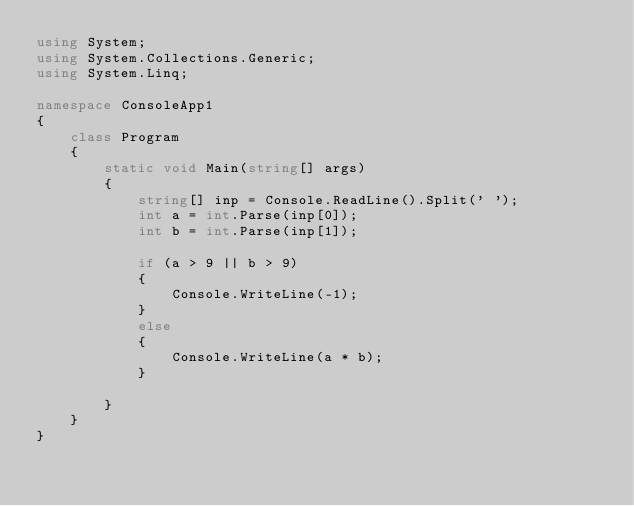Convert code to text. <code><loc_0><loc_0><loc_500><loc_500><_C#_>using System;
using System.Collections.Generic;
using System.Linq;

namespace ConsoleApp1
{
    class Program
    {
        static void Main(string[] args)
        {
            string[] inp = Console.ReadLine().Split(' ');
            int a = int.Parse(inp[0]);
            int b = int.Parse(inp[1]);

            if (a > 9 || b > 9)
            {
                Console.WriteLine(-1);
            }
            else
            {
                Console.WriteLine(a * b);
            }

        }
    }
}
</code> 